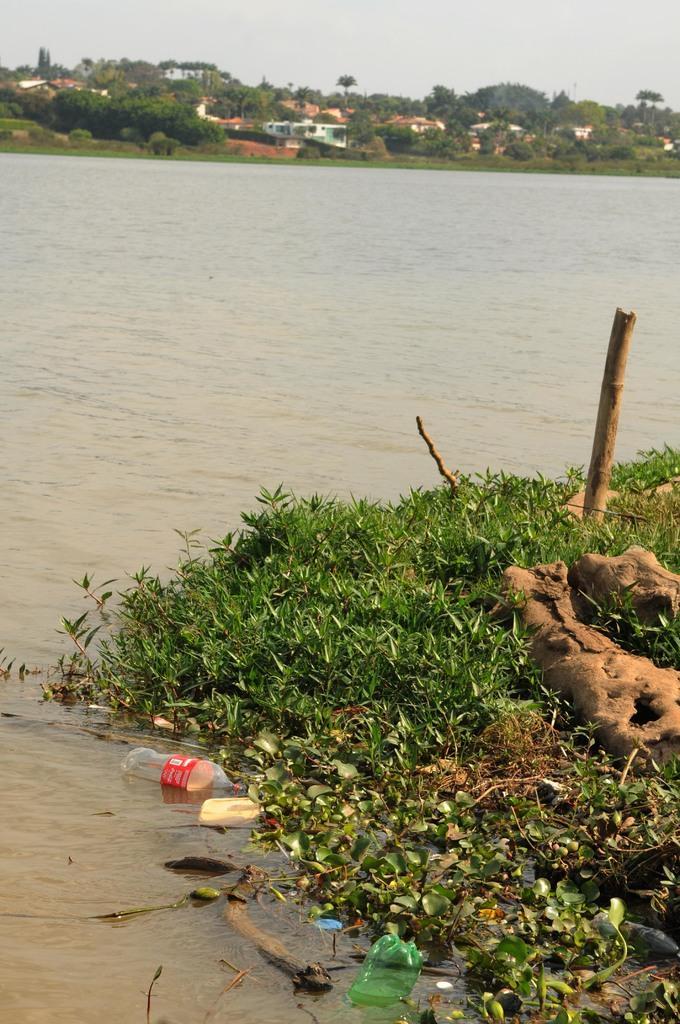Please provide a concise description of this image. In this picture I can observe some grass on the land. There is a river. I can observe some plastic bottles in the water. In the background there are trees, houses and a sky. 